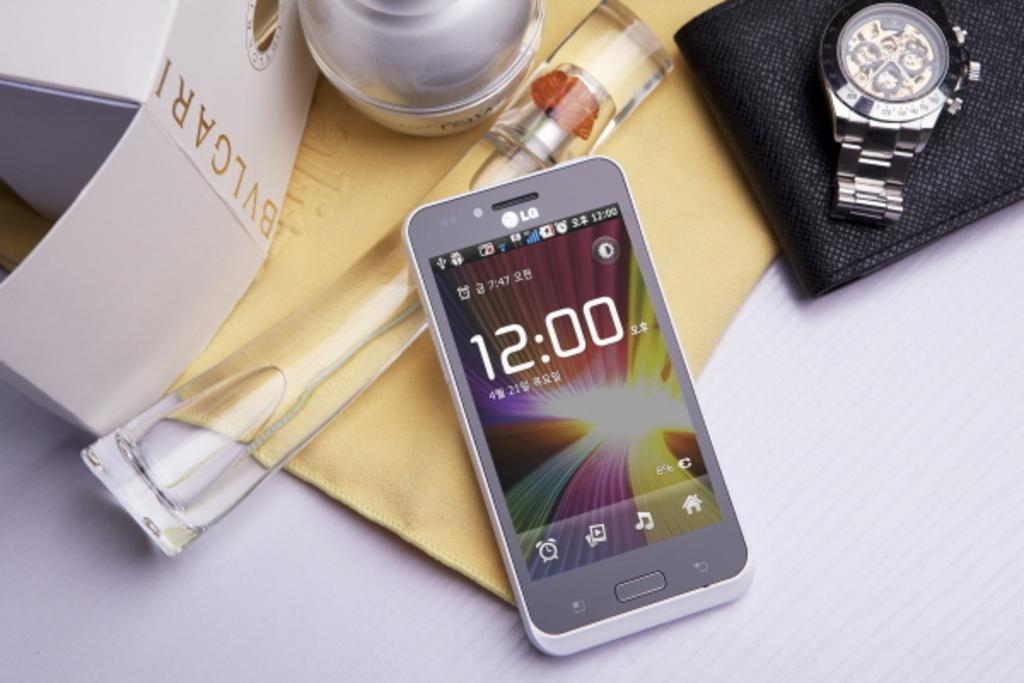<image>
Provide a brief description of the given image. An LG phone shows the time as 12:00 and sits next to BVLGARI white box, a watch, and flower in a glass stem. 